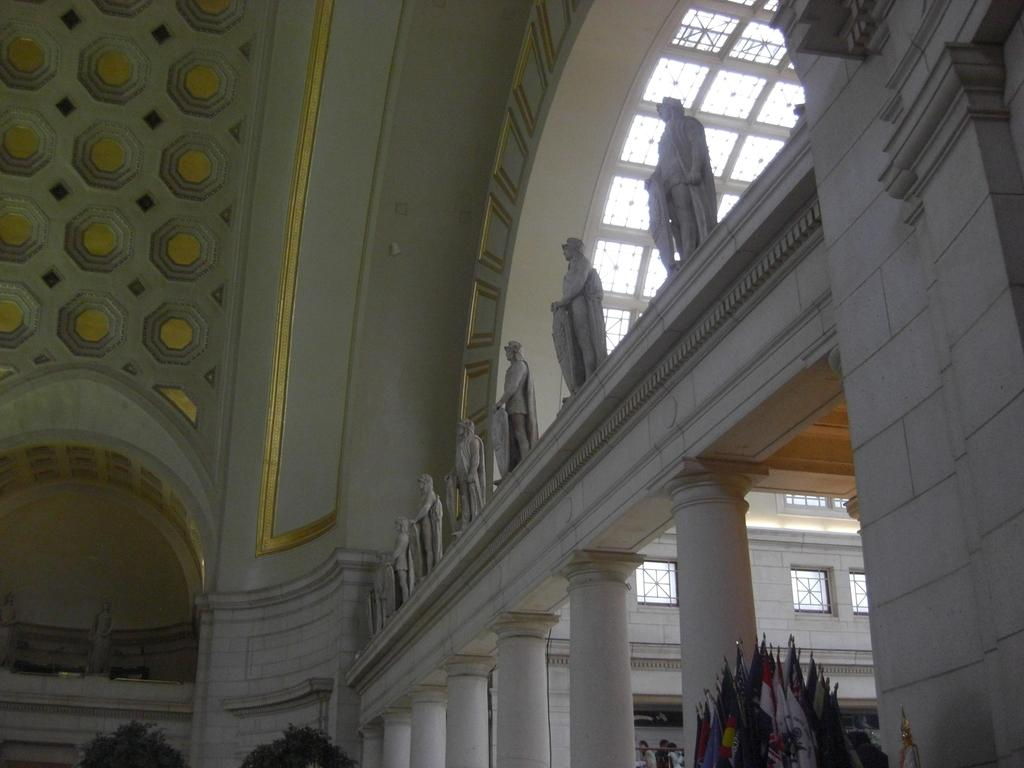What type of structure is visible in the image? There is a building in the image. What architectural features can be seen on the building? There are pillars visible in the image. What can be seen flying on the flag posts? There are flags in the image. What are the flag posts attached to? There are flag posts in the image. What type of decorative or artistic elements are present in the image? There are statues in the image. What might be used for reflecting light or images in the image? There are mirrors in the image. What type of thrill can be experienced at the government airport depicted in the image? The image does not depict a government airport, nor does it suggest any type of thrill. 